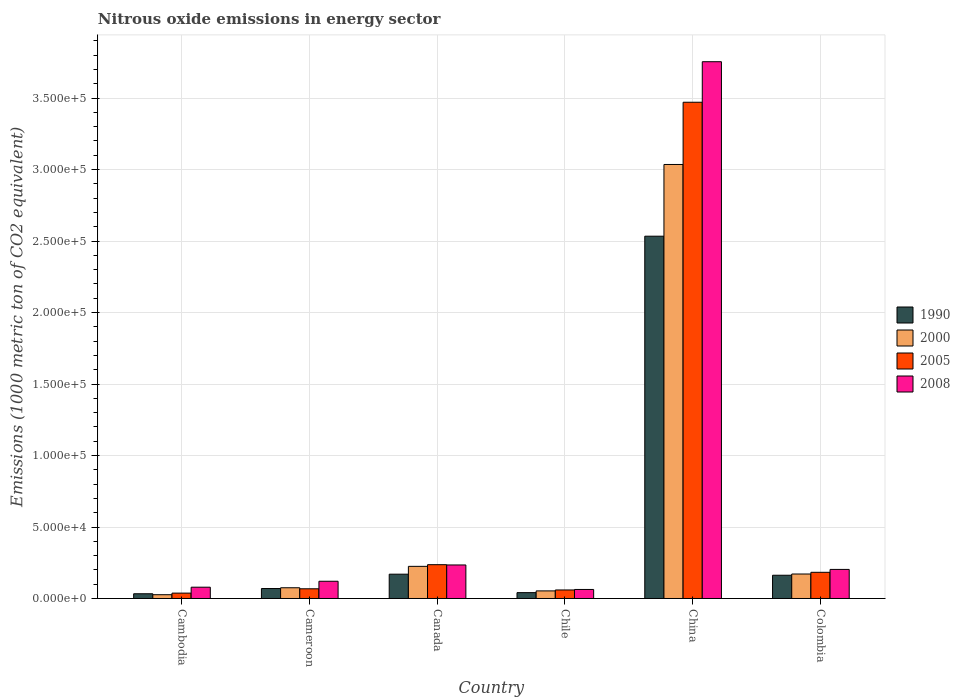How many different coloured bars are there?
Your answer should be very brief. 4. Are the number of bars on each tick of the X-axis equal?
Your answer should be compact. Yes. What is the label of the 6th group of bars from the left?
Make the answer very short. Colombia. What is the amount of nitrous oxide emitted in 2005 in China?
Make the answer very short. 3.47e+05. Across all countries, what is the maximum amount of nitrous oxide emitted in 1990?
Give a very brief answer. 2.53e+05. Across all countries, what is the minimum amount of nitrous oxide emitted in 2005?
Provide a short and direct response. 3761.1. In which country was the amount of nitrous oxide emitted in 2000 minimum?
Make the answer very short. Cambodia. What is the total amount of nitrous oxide emitted in 2008 in the graph?
Your response must be concise. 4.45e+05. What is the difference between the amount of nitrous oxide emitted in 2005 in Canada and that in Colombia?
Offer a very short reply. 5332.3. What is the difference between the amount of nitrous oxide emitted in 1990 in Canada and the amount of nitrous oxide emitted in 2000 in Cambodia?
Offer a very short reply. 1.44e+04. What is the average amount of nitrous oxide emitted in 2005 per country?
Your answer should be very brief. 6.76e+04. What is the difference between the amount of nitrous oxide emitted of/in 2008 and amount of nitrous oxide emitted of/in 1990 in Canada?
Provide a succinct answer. 6448.9. In how many countries, is the amount of nitrous oxide emitted in 2008 greater than 110000 1000 metric ton?
Give a very brief answer. 1. What is the ratio of the amount of nitrous oxide emitted in 1990 in Cameroon to that in Colombia?
Provide a short and direct response. 0.43. What is the difference between the highest and the second highest amount of nitrous oxide emitted in 2005?
Provide a succinct answer. -3.23e+05. What is the difference between the highest and the lowest amount of nitrous oxide emitted in 2000?
Your answer should be very brief. 3.01e+05. What does the 1st bar from the left in Chile represents?
Your answer should be compact. 1990. Is it the case that in every country, the sum of the amount of nitrous oxide emitted in 2008 and amount of nitrous oxide emitted in 2005 is greater than the amount of nitrous oxide emitted in 2000?
Make the answer very short. Yes. Are all the bars in the graph horizontal?
Offer a terse response. No. How many countries are there in the graph?
Provide a succinct answer. 6. Are the values on the major ticks of Y-axis written in scientific E-notation?
Give a very brief answer. Yes. Does the graph contain grids?
Offer a terse response. Yes. Where does the legend appear in the graph?
Make the answer very short. Center right. What is the title of the graph?
Your answer should be very brief. Nitrous oxide emissions in energy sector. Does "1964" appear as one of the legend labels in the graph?
Your response must be concise. No. What is the label or title of the X-axis?
Give a very brief answer. Country. What is the label or title of the Y-axis?
Keep it short and to the point. Emissions (1000 metric ton of CO2 equivalent). What is the Emissions (1000 metric ton of CO2 equivalent) in 1990 in Cambodia?
Ensure brevity in your answer.  3309.2. What is the Emissions (1000 metric ton of CO2 equivalent) of 2000 in Cambodia?
Your answer should be very brief. 2644.9. What is the Emissions (1000 metric ton of CO2 equivalent) in 2005 in Cambodia?
Provide a short and direct response. 3761.1. What is the Emissions (1000 metric ton of CO2 equivalent) in 2008 in Cambodia?
Give a very brief answer. 7902.7. What is the Emissions (1000 metric ton of CO2 equivalent) in 1990 in Cameroon?
Give a very brief answer. 6970.1. What is the Emissions (1000 metric ton of CO2 equivalent) of 2000 in Cameroon?
Give a very brief answer. 7501.6. What is the Emissions (1000 metric ton of CO2 equivalent) in 2005 in Cameroon?
Offer a very short reply. 6781.9. What is the Emissions (1000 metric ton of CO2 equivalent) in 2008 in Cameroon?
Your response must be concise. 1.21e+04. What is the Emissions (1000 metric ton of CO2 equivalent) in 1990 in Canada?
Offer a very short reply. 1.70e+04. What is the Emissions (1000 metric ton of CO2 equivalent) in 2000 in Canada?
Keep it short and to the point. 2.25e+04. What is the Emissions (1000 metric ton of CO2 equivalent) of 2005 in Canada?
Offer a very short reply. 2.36e+04. What is the Emissions (1000 metric ton of CO2 equivalent) of 2008 in Canada?
Offer a terse response. 2.34e+04. What is the Emissions (1000 metric ton of CO2 equivalent) in 1990 in Chile?
Provide a succinct answer. 4097. What is the Emissions (1000 metric ton of CO2 equivalent) in 2000 in Chile?
Offer a very short reply. 5305.7. What is the Emissions (1000 metric ton of CO2 equivalent) of 2005 in Chile?
Keep it short and to the point. 5967.8. What is the Emissions (1000 metric ton of CO2 equivalent) in 2008 in Chile?
Offer a very short reply. 6312. What is the Emissions (1000 metric ton of CO2 equivalent) of 1990 in China?
Provide a short and direct response. 2.53e+05. What is the Emissions (1000 metric ton of CO2 equivalent) in 2000 in China?
Your answer should be compact. 3.04e+05. What is the Emissions (1000 metric ton of CO2 equivalent) of 2005 in China?
Give a very brief answer. 3.47e+05. What is the Emissions (1000 metric ton of CO2 equivalent) of 2008 in China?
Provide a short and direct response. 3.75e+05. What is the Emissions (1000 metric ton of CO2 equivalent) of 1990 in Colombia?
Keep it short and to the point. 1.63e+04. What is the Emissions (1000 metric ton of CO2 equivalent) in 2000 in Colombia?
Make the answer very short. 1.71e+04. What is the Emissions (1000 metric ton of CO2 equivalent) of 2005 in Colombia?
Make the answer very short. 1.83e+04. What is the Emissions (1000 metric ton of CO2 equivalent) in 2008 in Colombia?
Keep it short and to the point. 2.03e+04. Across all countries, what is the maximum Emissions (1000 metric ton of CO2 equivalent) in 1990?
Offer a very short reply. 2.53e+05. Across all countries, what is the maximum Emissions (1000 metric ton of CO2 equivalent) of 2000?
Provide a succinct answer. 3.04e+05. Across all countries, what is the maximum Emissions (1000 metric ton of CO2 equivalent) in 2005?
Your answer should be compact. 3.47e+05. Across all countries, what is the maximum Emissions (1000 metric ton of CO2 equivalent) in 2008?
Provide a succinct answer. 3.75e+05. Across all countries, what is the minimum Emissions (1000 metric ton of CO2 equivalent) of 1990?
Provide a short and direct response. 3309.2. Across all countries, what is the minimum Emissions (1000 metric ton of CO2 equivalent) of 2000?
Ensure brevity in your answer.  2644.9. Across all countries, what is the minimum Emissions (1000 metric ton of CO2 equivalent) of 2005?
Offer a very short reply. 3761.1. Across all countries, what is the minimum Emissions (1000 metric ton of CO2 equivalent) in 2008?
Your response must be concise. 6312. What is the total Emissions (1000 metric ton of CO2 equivalent) of 1990 in the graph?
Keep it short and to the point. 3.01e+05. What is the total Emissions (1000 metric ton of CO2 equivalent) of 2000 in the graph?
Offer a terse response. 3.59e+05. What is the total Emissions (1000 metric ton of CO2 equivalent) of 2005 in the graph?
Make the answer very short. 4.06e+05. What is the total Emissions (1000 metric ton of CO2 equivalent) in 2008 in the graph?
Make the answer very short. 4.45e+05. What is the difference between the Emissions (1000 metric ton of CO2 equivalent) of 1990 in Cambodia and that in Cameroon?
Your answer should be compact. -3660.9. What is the difference between the Emissions (1000 metric ton of CO2 equivalent) of 2000 in Cambodia and that in Cameroon?
Offer a terse response. -4856.7. What is the difference between the Emissions (1000 metric ton of CO2 equivalent) in 2005 in Cambodia and that in Cameroon?
Offer a terse response. -3020.8. What is the difference between the Emissions (1000 metric ton of CO2 equivalent) of 2008 in Cambodia and that in Cameroon?
Provide a succinct answer. -4150.2. What is the difference between the Emissions (1000 metric ton of CO2 equivalent) in 1990 in Cambodia and that in Canada?
Offer a very short reply. -1.37e+04. What is the difference between the Emissions (1000 metric ton of CO2 equivalent) in 2000 in Cambodia and that in Canada?
Give a very brief answer. -1.98e+04. What is the difference between the Emissions (1000 metric ton of CO2 equivalent) in 2005 in Cambodia and that in Canada?
Give a very brief answer. -1.99e+04. What is the difference between the Emissions (1000 metric ton of CO2 equivalent) in 2008 in Cambodia and that in Canada?
Your answer should be very brief. -1.55e+04. What is the difference between the Emissions (1000 metric ton of CO2 equivalent) in 1990 in Cambodia and that in Chile?
Offer a very short reply. -787.8. What is the difference between the Emissions (1000 metric ton of CO2 equivalent) of 2000 in Cambodia and that in Chile?
Make the answer very short. -2660.8. What is the difference between the Emissions (1000 metric ton of CO2 equivalent) in 2005 in Cambodia and that in Chile?
Give a very brief answer. -2206.7. What is the difference between the Emissions (1000 metric ton of CO2 equivalent) in 2008 in Cambodia and that in Chile?
Keep it short and to the point. 1590.7. What is the difference between the Emissions (1000 metric ton of CO2 equivalent) in 1990 in Cambodia and that in China?
Make the answer very short. -2.50e+05. What is the difference between the Emissions (1000 metric ton of CO2 equivalent) in 2000 in Cambodia and that in China?
Your answer should be compact. -3.01e+05. What is the difference between the Emissions (1000 metric ton of CO2 equivalent) in 2005 in Cambodia and that in China?
Give a very brief answer. -3.43e+05. What is the difference between the Emissions (1000 metric ton of CO2 equivalent) in 2008 in Cambodia and that in China?
Your answer should be compact. -3.68e+05. What is the difference between the Emissions (1000 metric ton of CO2 equivalent) in 1990 in Cambodia and that in Colombia?
Give a very brief answer. -1.30e+04. What is the difference between the Emissions (1000 metric ton of CO2 equivalent) of 2000 in Cambodia and that in Colombia?
Give a very brief answer. -1.45e+04. What is the difference between the Emissions (1000 metric ton of CO2 equivalent) of 2005 in Cambodia and that in Colombia?
Your response must be concise. -1.45e+04. What is the difference between the Emissions (1000 metric ton of CO2 equivalent) of 2008 in Cambodia and that in Colombia?
Your answer should be very brief. -1.24e+04. What is the difference between the Emissions (1000 metric ton of CO2 equivalent) in 1990 in Cameroon and that in Canada?
Offer a very short reply. -1.00e+04. What is the difference between the Emissions (1000 metric ton of CO2 equivalent) in 2000 in Cameroon and that in Canada?
Offer a very short reply. -1.50e+04. What is the difference between the Emissions (1000 metric ton of CO2 equivalent) in 2005 in Cameroon and that in Canada?
Keep it short and to the point. -1.69e+04. What is the difference between the Emissions (1000 metric ton of CO2 equivalent) of 2008 in Cameroon and that in Canada?
Give a very brief answer. -1.14e+04. What is the difference between the Emissions (1000 metric ton of CO2 equivalent) of 1990 in Cameroon and that in Chile?
Your answer should be compact. 2873.1. What is the difference between the Emissions (1000 metric ton of CO2 equivalent) in 2000 in Cameroon and that in Chile?
Offer a terse response. 2195.9. What is the difference between the Emissions (1000 metric ton of CO2 equivalent) of 2005 in Cameroon and that in Chile?
Make the answer very short. 814.1. What is the difference between the Emissions (1000 metric ton of CO2 equivalent) of 2008 in Cameroon and that in Chile?
Offer a very short reply. 5740.9. What is the difference between the Emissions (1000 metric ton of CO2 equivalent) in 1990 in Cameroon and that in China?
Your answer should be compact. -2.46e+05. What is the difference between the Emissions (1000 metric ton of CO2 equivalent) in 2000 in Cameroon and that in China?
Offer a terse response. -2.96e+05. What is the difference between the Emissions (1000 metric ton of CO2 equivalent) of 2005 in Cameroon and that in China?
Give a very brief answer. -3.40e+05. What is the difference between the Emissions (1000 metric ton of CO2 equivalent) in 2008 in Cameroon and that in China?
Your answer should be very brief. -3.63e+05. What is the difference between the Emissions (1000 metric ton of CO2 equivalent) of 1990 in Cameroon and that in Colombia?
Offer a terse response. -9292. What is the difference between the Emissions (1000 metric ton of CO2 equivalent) in 2000 in Cameroon and that in Colombia?
Provide a succinct answer. -9624.9. What is the difference between the Emissions (1000 metric ton of CO2 equivalent) of 2005 in Cameroon and that in Colombia?
Make the answer very short. -1.15e+04. What is the difference between the Emissions (1000 metric ton of CO2 equivalent) in 2008 in Cameroon and that in Colombia?
Your response must be concise. -8286.7. What is the difference between the Emissions (1000 metric ton of CO2 equivalent) of 1990 in Canada and that in Chile?
Your answer should be compact. 1.29e+04. What is the difference between the Emissions (1000 metric ton of CO2 equivalent) of 2000 in Canada and that in Chile?
Your answer should be compact. 1.72e+04. What is the difference between the Emissions (1000 metric ton of CO2 equivalent) of 2005 in Canada and that in Chile?
Offer a terse response. 1.77e+04. What is the difference between the Emissions (1000 metric ton of CO2 equivalent) of 2008 in Canada and that in Chile?
Offer a very short reply. 1.71e+04. What is the difference between the Emissions (1000 metric ton of CO2 equivalent) in 1990 in Canada and that in China?
Provide a succinct answer. -2.36e+05. What is the difference between the Emissions (1000 metric ton of CO2 equivalent) of 2000 in Canada and that in China?
Keep it short and to the point. -2.81e+05. What is the difference between the Emissions (1000 metric ton of CO2 equivalent) in 2005 in Canada and that in China?
Your answer should be very brief. -3.23e+05. What is the difference between the Emissions (1000 metric ton of CO2 equivalent) of 2008 in Canada and that in China?
Provide a short and direct response. -3.52e+05. What is the difference between the Emissions (1000 metric ton of CO2 equivalent) of 1990 in Canada and that in Colombia?
Your answer should be very brief. 737.3. What is the difference between the Emissions (1000 metric ton of CO2 equivalent) in 2000 in Canada and that in Colombia?
Make the answer very short. 5354.3. What is the difference between the Emissions (1000 metric ton of CO2 equivalent) of 2005 in Canada and that in Colombia?
Your answer should be compact. 5332.3. What is the difference between the Emissions (1000 metric ton of CO2 equivalent) of 2008 in Canada and that in Colombia?
Keep it short and to the point. 3108.7. What is the difference between the Emissions (1000 metric ton of CO2 equivalent) in 1990 in Chile and that in China?
Provide a short and direct response. -2.49e+05. What is the difference between the Emissions (1000 metric ton of CO2 equivalent) in 2000 in Chile and that in China?
Offer a very short reply. -2.98e+05. What is the difference between the Emissions (1000 metric ton of CO2 equivalent) of 2005 in Chile and that in China?
Offer a very short reply. -3.41e+05. What is the difference between the Emissions (1000 metric ton of CO2 equivalent) of 2008 in Chile and that in China?
Offer a terse response. -3.69e+05. What is the difference between the Emissions (1000 metric ton of CO2 equivalent) in 1990 in Chile and that in Colombia?
Give a very brief answer. -1.22e+04. What is the difference between the Emissions (1000 metric ton of CO2 equivalent) in 2000 in Chile and that in Colombia?
Provide a succinct answer. -1.18e+04. What is the difference between the Emissions (1000 metric ton of CO2 equivalent) of 2005 in Chile and that in Colombia?
Offer a very short reply. -1.23e+04. What is the difference between the Emissions (1000 metric ton of CO2 equivalent) of 2008 in Chile and that in Colombia?
Your answer should be very brief. -1.40e+04. What is the difference between the Emissions (1000 metric ton of CO2 equivalent) of 1990 in China and that in Colombia?
Make the answer very short. 2.37e+05. What is the difference between the Emissions (1000 metric ton of CO2 equivalent) of 2000 in China and that in Colombia?
Provide a succinct answer. 2.86e+05. What is the difference between the Emissions (1000 metric ton of CO2 equivalent) in 2005 in China and that in Colombia?
Keep it short and to the point. 3.29e+05. What is the difference between the Emissions (1000 metric ton of CO2 equivalent) of 2008 in China and that in Colombia?
Your answer should be very brief. 3.55e+05. What is the difference between the Emissions (1000 metric ton of CO2 equivalent) of 1990 in Cambodia and the Emissions (1000 metric ton of CO2 equivalent) of 2000 in Cameroon?
Offer a very short reply. -4192.4. What is the difference between the Emissions (1000 metric ton of CO2 equivalent) in 1990 in Cambodia and the Emissions (1000 metric ton of CO2 equivalent) in 2005 in Cameroon?
Ensure brevity in your answer.  -3472.7. What is the difference between the Emissions (1000 metric ton of CO2 equivalent) in 1990 in Cambodia and the Emissions (1000 metric ton of CO2 equivalent) in 2008 in Cameroon?
Make the answer very short. -8743.7. What is the difference between the Emissions (1000 metric ton of CO2 equivalent) of 2000 in Cambodia and the Emissions (1000 metric ton of CO2 equivalent) of 2005 in Cameroon?
Keep it short and to the point. -4137. What is the difference between the Emissions (1000 metric ton of CO2 equivalent) in 2000 in Cambodia and the Emissions (1000 metric ton of CO2 equivalent) in 2008 in Cameroon?
Make the answer very short. -9408. What is the difference between the Emissions (1000 metric ton of CO2 equivalent) of 2005 in Cambodia and the Emissions (1000 metric ton of CO2 equivalent) of 2008 in Cameroon?
Keep it short and to the point. -8291.8. What is the difference between the Emissions (1000 metric ton of CO2 equivalent) in 1990 in Cambodia and the Emissions (1000 metric ton of CO2 equivalent) in 2000 in Canada?
Ensure brevity in your answer.  -1.92e+04. What is the difference between the Emissions (1000 metric ton of CO2 equivalent) of 1990 in Cambodia and the Emissions (1000 metric ton of CO2 equivalent) of 2005 in Canada?
Give a very brief answer. -2.03e+04. What is the difference between the Emissions (1000 metric ton of CO2 equivalent) in 1990 in Cambodia and the Emissions (1000 metric ton of CO2 equivalent) in 2008 in Canada?
Make the answer very short. -2.01e+04. What is the difference between the Emissions (1000 metric ton of CO2 equivalent) of 2000 in Cambodia and the Emissions (1000 metric ton of CO2 equivalent) of 2005 in Canada?
Your response must be concise. -2.10e+04. What is the difference between the Emissions (1000 metric ton of CO2 equivalent) of 2000 in Cambodia and the Emissions (1000 metric ton of CO2 equivalent) of 2008 in Canada?
Keep it short and to the point. -2.08e+04. What is the difference between the Emissions (1000 metric ton of CO2 equivalent) of 2005 in Cambodia and the Emissions (1000 metric ton of CO2 equivalent) of 2008 in Canada?
Ensure brevity in your answer.  -1.97e+04. What is the difference between the Emissions (1000 metric ton of CO2 equivalent) in 1990 in Cambodia and the Emissions (1000 metric ton of CO2 equivalent) in 2000 in Chile?
Ensure brevity in your answer.  -1996.5. What is the difference between the Emissions (1000 metric ton of CO2 equivalent) in 1990 in Cambodia and the Emissions (1000 metric ton of CO2 equivalent) in 2005 in Chile?
Keep it short and to the point. -2658.6. What is the difference between the Emissions (1000 metric ton of CO2 equivalent) of 1990 in Cambodia and the Emissions (1000 metric ton of CO2 equivalent) of 2008 in Chile?
Provide a short and direct response. -3002.8. What is the difference between the Emissions (1000 metric ton of CO2 equivalent) of 2000 in Cambodia and the Emissions (1000 metric ton of CO2 equivalent) of 2005 in Chile?
Make the answer very short. -3322.9. What is the difference between the Emissions (1000 metric ton of CO2 equivalent) in 2000 in Cambodia and the Emissions (1000 metric ton of CO2 equivalent) in 2008 in Chile?
Make the answer very short. -3667.1. What is the difference between the Emissions (1000 metric ton of CO2 equivalent) in 2005 in Cambodia and the Emissions (1000 metric ton of CO2 equivalent) in 2008 in Chile?
Your response must be concise. -2550.9. What is the difference between the Emissions (1000 metric ton of CO2 equivalent) of 1990 in Cambodia and the Emissions (1000 metric ton of CO2 equivalent) of 2000 in China?
Your answer should be compact. -3.00e+05. What is the difference between the Emissions (1000 metric ton of CO2 equivalent) of 1990 in Cambodia and the Emissions (1000 metric ton of CO2 equivalent) of 2005 in China?
Provide a short and direct response. -3.44e+05. What is the difference between the Emissions (1000 metric ton of CO2 equivalent) in 1990 in Cambodia and the Emissions (1000 metric ton of CO2 equivalent) in 2008 in China?
Provide a succinct answer. -3.72e+05. What is the difference between the Emissions (1000 metric ton of CO2 equivalent) in 2000 in Cambodia and the Emissions (1000 metric ton of CO2 equivalent) in 2005 in China?
Ensure brevity in your answer.  -3.44e+05. What is the difference between the Emissions (1000 metric ton of CO2 equivalent) of 2000 in Cambodia and the Emissions (1000 metric ton of CO2 equivalent) of 2008 in China?
Keep it short and to the point. -3.73e+05. What is the difference between the Emissions (1000 metric ton of CO2 equivalent) of 2005 in Cambodia and the Emissions (1000 metric ton of CO2 equivalent) of 2008 in China?
Your response must be concise. -3.72e+05. What is the difference between the Emissions (1000 metric ton of CO2 equivalent) in 1990 in Cambodia and the Emissions (1000 metric ton of CO2 equivalent) in 2000 in Colombia?
Offer a very short reply. -1.38e+04. What is the difference between the Emissions (1000 metric ton of CO2 equivalent) of 1990 in Cambodia and the Emissions (1000 metric ton of CO2 equivalent) of 2005 in Colombia?
Offer a terse response. -1.50e+04. What is the difference between the Emissions (1000 metric ton of CO2 equivalent) of 1990 in Cambodia and the Emissions (1000 metric ton of CO2 equivalent) of 2008 in Colombia?
Provide a short and direct response. -1.70e+04. What is the difference between the Emissions (1000 metric ton of CO2 equivalent) in 2000 in Cambodia and the Emissions (1000 metric ton of CO2 equivalent) in 2005 in Colombia?
Your answer should be very brief. -1.57e+04. What is the difference between the Emissions (1000 metric ton of CO2 equivalent) in 2000 in Cambodia and the Emissions (1000 metric ton of CO2 equivalent) in 2008 in Colombia?
Make the answer very short. -1.77e+04. What is the difference between the Emissions (1000 metric ton of CO2 equivalent) of 2005 in Cambodia and the Emissions (1000 metric ton of CO2 equivalent) of 2008 in Colombia?
Make the answer very short. -1.66e+04. What is the difference between the Emissions (1000 metric ton of CO2 equivalent) in 1990 in Cameroon and the Emissions (1000 metric ton of CO2 equivalent) in 2000 in Canada?
Ensure brevity in your answer.  -1.55e+04. What is the difference between the Emissions (1000 metric ton of CO2 equivalent) in 1990 in Cameroon and the Emissions (1000 metric ton of CO2 equivalent) in 2005 in Canada?
Offer a terse response. -1.67e+04. What is the difference between the Emissions (1000 metric ton of CO2 equivalent) of 1990 in Cameroon and the Emissions (1000 metric ton of CO2 equivalent) of 2008 in Canada?
Keep it short and to the point. -1.65e+04. What is the difference between the Emissions (1000 metric ton of CO2 equivalent) in 2000 in Cameroon and the Emissions (1000 metric ton of CO2 equivalent) in 2005 in Canada?
Make the answer very short. -1.61e+04. What is the difference between the Emissions (1000 metric ton of CO2 equivalent) in 2000 in Cameroon and the Emissions (1000 metric ton of CO2 equivalent) in 2008 in Canada?
Your response must be concise. -1.59e+04. What is the difference between the Emissions (1000 metric ton of CO2 equivalent) of 2005 in Cameroon and the Emissions (1000 metric ton of CO2 equivalent) of 2008 in Canada?
Ensure brevity in your answer.  -1.67e+04. What is the difference between the Emissions (1000 metric ton of CO2 equivalent) in 1990 in Cameroon and the Emissions (1000 metric ton of CO2 equivalent) in 2000 in Chile?
Provide a short and direct response. 1664.4. What is the difference between the Emissions (1000 metric ton of CO2 equivalent) in 1990 in Cameroon and the Emissions (1000 metric ton of CO2 equivalent) in 2005 in Chile?
Ensure brevity in your answer.  1002.3. What is the difference between the Emissions (1000 metric ton of CO2 equivalent) of 1990 in Cameroon and the Emissions (1000 metric ton of CO2 equivalent) of 2008 in Chile?
Keep it short and to the point. 658.1. What is the difference between the Emissions (1000 metric ton of CO2 equivalent) of 2000 in Cameroon and the Emissions (1000 metric ton of CO2 equivalent) of 2005 in Chile?
Make the answer very short. 1533.8. What is the difference between the Emissions (1000 metric ton of CO2 equivalent) in 2000 in Cameroon and the Emissions (1000 metric ton of CO2 equivalent) in 2008 in Chile?
Provide a succinct answer. 1189.6. What is the difference between the Emissions (1000 metric ton of CO2 equivalent) in 2005 in Cameroon and the Emissions (1000 metric ton of CO2 equivalent) in 2008 in Chile?
Provide a short and direct response. 469.9. What is the difference between the Emissions (1000 metric ton of CO2 equivalent) of 1990 in Cameroon and the Emissions (1000 metric ton of CO2 equivalent) of 2000 in China?
Provide a succinct answer. -2.97e+05. What is the difference between the Emissions (1000 metric ton of CO2 equivalent) in 1990 in Cameroon and the Emissions (1000 metric ton of CO2 equivalent) in 2005 in China?
Offer a terse response. -3.40e+05. What is the difference between the Emissions (1000 metric ton of CO2 equivalent) of 1990 in Cameroon and the Emissions (1000 metric ton of CO2 equivalent) of 2008 in China?
Your response must be concise. -3.68e+05. What is the difference between the Emissions (1000 metric ton of CO2 equivalent) in 2000 in Cameroon and the Emissions (1000 metric ton of CO2 equivalent) in 2005 in China?
Your answer should be very brief. -3.40e+05. What is the difference between the Emissions (1000 metric ton of CO2 equivalent) of 2000 in Cameroon and the Emissions (1000 metric ton of CO2 equivalent) of 2008 in China?
Keep it short and to the point. -3.68e+05. What is the difference between the Emissions (1000 metric ton of CO2 equivalent) in 2005 in Cameroon and the Emissions (1000 metric ton of CO2 equivalent) in 2008 in China?
Ensure brevity in your answer.  -3.69e+05. What is the difference between the Emissions (1000 metric ton of CO2 equivalent) of 1990 in Cameroon and the Emissions (1000 metric ton of CO2 equivalent) of 2000 in Colombia?
Provide a succinct answer. -1.02e+04. What is the difference between the Emissions (1000 metric ton of CO2 equivalent) in 1990 in Cameroon and the Emissions (1000 metric ton of CO2 equivalent) in 2005 in Colombia?
Provide a short and direct response. -1.13e+04. What is the difference between the Emissions (1000 metric ton of CO2 equivalent) of 1990 in Cameroon and the Emissions (1000 metric ton of CO2 equivalent) of 2008 in Colombia?
Provide a succinct answer. -1.34e+04. What is the difference between the Emissions (1000 metric ton of CO2 equivalent) in 2000 in Cameroon and the Emissions (1000 metric ton of CO2 equivalent) in 2005 in Colombia?
Your answer should be very brief. -1.08e+04. What is the difference between the Emissions (1000 metric ton of CO2 equivalent) in 2000 in Cameroon and the Emissions (1000 metric ton of CO2 equivalent) in 2008 in Colombia?
Offer a very short reply. -1.28e+04. What is the difference between the Emissions (1000 metric ton of CO2 equivalent) of 2005 in Cameroon and the Emissions (1000 metric ton of CO2 equivalent) of 2008 in Colombia?
Offer a terse response. -1.36e+04. What is the difference between the Emissions (1000 metric ton of CO2 equivalent) in 1990 in Canada and the Emissions (1000 metric ton of CO2 equivalent) in 2000 in Chile?
Offer a very short reply. 1.17e+04. What is the difference between the Emissions (1000 metric ton of CO2 equivalent) in 1990 in Canada and the Emissions (1000 metric ton of CO2 equivalent) in 2005 in Chile?
Provide a succinct answer. 1.10e+04. What is the difference between the Emissions (1000 metric ton of CO2 equivalent) of 1990 in Canada and the Emissions (1000 metric ton of CO2 equivalent) of 2008 in Chile?
Your answer should be very brief. 1.07e+04. What is the difference between the Emissions (1000 metric ton of CO2 equivalent) in 2000 in Canada and the Emissions (1000 metric ton of CO2 equivalent) in 2005 in Chile?
Keep it short and to the point. 1.65e+04. What is the difference between the Emissions (1000 metric ton of CO2 equivalent) of 2000 in Canada and the Emissions (1000 metric ton of CO2 equivalent) of 2008 in Chile?
Ensure brevity in your answer.  1.62e+04. What is the difference between the Emissions (1000 metric ton of CO2 equivalent) of 2005 in Canada and the Emissions (1000 metric ton of CO2 equivalent) of 2008 in Chile?
Provide a succinct answer. 1.73e+04. What is the difference between the Emissions (1000 metric ton of CO2 equivalent) of 1990 in Canada and the Emissions (1000 metric ton of CO2 equivalent) of 2000 in China?
Give a very brief answer. -2.87e+05. What is the difference between the Emissions (1000 metric ton of CO2 equivalent) of 1990 in Canada and the Emissions (1000 metric ton of CO2 equivalent) of 2005 in China?
Offer a very short reply. -3.30e+05. What is the difference between the Emissions (1000 metric ton of CO2 equivalent) in 1990 in Canada and the Emissions (1000 metric ton of CO2 equivalent) in 2008 in China?
Make the answer very short. -3.58e+05. What is the difference between the Emissions (1000 metric ton of CO2 equivalent) of 2000 in Canada and the Emissions (1000 metric ton of CO2 equivalent) of 2005 in China?
Ensure brevity in your answer.  -3.25e+05. What is the difference between the Emissions (1000 metric ton of CO2 equivalent) in 2000 in Canada and the Emissions (1000 metric ton of CO2 equivalent) in 2008 in China?
Your answer should be compact. -3.53e+05. What is the difference between the Emissions (1000 metric ton of CO2 equivalent) in 2005 in Canada and the Emissions (1000 metric ton of CO2 equivalent) in 2008 in China?
Make the answer very short. -3.52e+05. What is the difference between the Emissions (1000 metric ton of CO2 equivalent) in 1990 in Canada and the Emissions (1000 metric ton of CO2 equivalent) in 2000 in Colombia?
Offer a terse response. -127.1. What is the difference between the Emissions (1000 metric ton of CO2 equivalent) in 1990 in Canada and the Emissions (1000 metric ton of CO2 equivalent) in 2005 in Colombia?
Give a very brief answer. -1310.3. What is the difference between the Emissions (1000 metric ton of CO2 equivalent) in 1990 in Canada and the Emissions (1000 metric ton of CO2 equivalent) in 2008 in Colombia?
Give a very brief answer. -3340.2. What is the difference between the Emissions (1000 metric ton of CO2 equivalent) in 2000 in Canada and the Emissions (1000 metric ton of CO2 equivalent) in 2005 in Colombia?
Make the answer very short. 4171.1. What is the difference between the Emissions (1000 metric ton of CO2 equivalent) of 2000 in Canada and the Emissions (1000 metric ton of CO2 equivalent) of 2008 in Colombia?
Provide a short and direct response. 2141.2. What is the difference between the Emissions (1000 metric ton of CO2 equivalent) in 2005 in Canada and the Emissions (1000 metric ton of CO2 equivalent) in 2008 in Colombia?
Give a very brief answer. 3302.4. What is the difference between the Emissions (1000 metric ton of CO2 equivalent) in 1990 in Chile and the Emissions (1000 metric ton of CO2 equivalent) in 2000 in China?
Your response must be concise. -2.99e+05. What is the difference between the Emissions (1000 metric ton of CO2 equivalent) of 1990 in Chile and the Emissions (1000 metric ton of CO2 equivalent) of 2005 in China?
Offer a very short reply. -3.43e+05. What is the difference between the Emissions (1000 metric ton of CO2 equivalent) in 1990 in Chile and the Emissions (1000 metric ton of CO2 equivalent) in 2008 in China?
Your response must be concise. -3.71e+05. What is the difference between the Emissions (1000 metric ton of CO2 equivalent) in 2000 in Chile and the Emissions (1000 metric ton of CO2 equivalent) in 2005 in China?
Give a very brief answer. -3.42e+05. What is the difference between the Emissions (1000 metric ton of CO2 equivalent) of 2000 in Chile and the Emissions (1000 metric ton of CO2 equivalent) of 2008 in China?
Your response must be concise. -3.70e+05. What is the difference between the Emissions (1000 metric ton of CO2 equivalent) in 2005 in Chile and the Emissions (1000 metric ton of CO2 equivalent) in 2008 in China?
Your response must be concise. -3.69e+05. What is the difference between the Emissions (1000 metric ton of CO2 equivalent) in 1990 in Chile and the Emissions (1000 metric ton of CO2 equivalent) in 2000 in Colombia?
Offer a terse response. -1.30e+04. What is the difference between the Emissions (1000 metric ton of CO2 equivalent) in 1990 in Chile and the Emissions (1000 metric ton of CO2 equivalent) in 2005 in Colombia?
Give a very brief answer. -1.42e+04. What is the difference between the Emissions (1000 metric ton of CO2 equivalent) of 1990 in Chile and the Emissions (1000 metric ton of CO2 equivalent) of 2008 in Colombia?
Your response must be concise. -1.62e+04. What is the difference between the Emissions (1000 metric ton of CO2 equivalent) in 2000 in Chile and the Emissions (1000 metric ton of CO2 equivalent) in 2005 in Colombia?
Provide a short and direct response. -1.30e+04. What is the difference between the Emissions (1000 metric ton of CO2 equivalent) of 2000 in Chile and the Emissions (1000 metric ton of CO2 equivalent) of 2008 in Colombia?
Offer a very short reply. -1.50e+04. What is the difference between the Emissions (1000 metric ton of CO2 equivalent) in 2005 in Chile and the Emissions (1000 metric ton of CO2 equivalent) in 2008 in Colombia?
Your answer should be very brief. -1.44e+04. What is the difference between the Emissions (1000 metric ton of CO2 equivalent) in 1990 in China and the Emissions (1000 metric ton of CO2 equivalent) in 2000 in Colombia?
Provide a succinct answer. 2.36e+05. What is the difference between the Emissions (1000 metric ton of CO2 equivalent) of 1990 in China and the Emissions (1000 metric ton of CO2 equivalent) of 2005 in Colombia?
Offer a very short reply. 2.35e+05. What is the difference between the Emissions (1000 metric ton of CO2 equivalent) of 1990 in China and the Emissions (1000 metric ton of CO2 equivalent) of 2008 in Colombia?
Provide a succinct answer. 2.33e+05. What is the difference between the Emissions (1000 metric ton of CO2 equivalent) of 2000 in China and the Emissions (1000 metric ton of CO2 equivalent) of 2005 in Colombia?
Your answer should be very brief. 2.85e+05. What is the difference between the Emissions (1000 metric ton of CO2 equivalent) in 2000 in China and the Emissions (1000 metric ton of CO2 equivalent) in 2008 in Colombia?
Your answer should be very brief. 2.83e+05. What is the difference between the Emissions (1000 metric ton of CO2 equivalent) of 2005 in China and the Emissions (1000 metric ton of CO2 equivalent) of 2008 in Colombia?
Provide a short and direct response. 3.27e+05. What is the average Emissions (1000 metric ton of CO2 equivalent) in 1990 per country?
Offer a terse response. 5.02e+04. What is the average Emissions (1000 metric ton of CO2 equivalent) in 2000 per country?
Offer a terse response. 5.98e+04. What is the average Emissions (1000 metric ton of CO2 equivalent) of 2005 per country?
Offer a terse response. 6.76e+04. What is the average Emissions (1000 metric ton of CO2 equivalent) of 2008 per country?
Your answer should be very brief. 7.42e+04. What is the difference between the Emissions (1000 metric ton of CO2 equivalent) of 1990 and Emissions (1000 metric ton of CO2 equivalent) of 2000 in Cambodia?
Keep it short and to the point. 664.3. What is the difference between the Emissions (1000 metric ton of CO2 equivalent) of 1990 and Emissions (1000 metric ton of CO2 equivalent) of 2005 in Cambodia?
Your response must be concise. -451.9. What is the difference between the Emissions (1000 metric ton of CO2 equivalent) of 1990 and Emissions (1000 metric ton of CO2 equivalent) of 2008 in Cambodia?
Keep it short and to the point. -4593.5. What is the difference between the Emissions (1000 metric ton of CO2 equivalent) of 2000 and Emissions (1000 metric ton of CO2 equivalent) of 2005 in Cambodia?
Your response must be concise. -1116.2. What is the difference between the Emissions (1000 metric ton of CO2 equivalent) of 2000 and Emissions (1000 metric ton of CO2 equivalent) of 2008 in Cambodia?
Provide a succinct answer. -5257.8. What is the difference between the Emissions (1000 metric ton of CO2 equivalent) in 2005 and Emissions (1000 metric ton of CO2 equivalent) in 2008 in Cambodia?
Keep it short and to the point. -4141.6. What is the difference between the Emissions (1000 metric ton of CO2 equivalent) of 1990 and Emissions (1000 metric ton of CO2 equivalent) of 2000 in Cameroon?
Provide a short and direct response. -531.5. What is the difference between the Emissions (1000 metric ton of CO2 equivalent) in 1990 and Emissions (1000 metric ton of CO2 equivalent) in 2005 in Cameroon?
Your answer should be very brief. 188.2. What is the difference between the Emissions (1000 metric ton of CO2 equivalent) of 1990 and Emissions (1000 metric ton of CO2 equivalent) of 2008 in Cameroon?
Provide a succinct answer. -5082.8. What is the difference between the Emissions (1000 metric ton of CO2 equivalent) of 2000 and Emissions (1000 metric ton of CO2 equivalent) of 2005 in Cameroon?
Your answer should be very brief. 719.7. What is the difference between the Emissions (1000 metric ton of CO2 equivalent) of 2000 and Emissions (1000 metric ton of CO2 equivalent) of 2008 in Cameroon?
Ensure brevity in your answer.  -4551.3. What is the difference between the Emissions (1000 metric ton of CO2 equivalent) of 2005 and Emissions (1000 metric ton of CO2 equivalent) of 2008 in Cameroon?
Offer a very short reply. -5271. What is the difference between the Emissions (1000 metric ton of CO2 equivalent) of 1990 and Emissions (1000 metric ton of CO2 equivalent) of 2000 in Canada?
Ensure brevity in your answer.  -5481.4. What is the difference between the Emissions (1000 metric ton of CO2 equivalent) in 1990 and Emissions (1000 metric ton of CO2 equivalent) in 2005 in Canada?
Make the answer very short. -6642.6. What is the difference between the Emissions (1000 metric ton of CO2 equivalent) of 1990 and Emissions (1000 metric ton of CO2 equivalent) of 2008 in Canada?
Make the answer very short. -6448.9. What is the difference between the Emissions (1000 metric ton of CO2 equivalent) in 2000 and Emissions (1000 metric ton of CO2 equivalent) in 2005 in Canada?
Give a very brief answer. -1161.2. What is the difference between the Emissions (1000 metric ton of CO2 equivalent) of 2000 and Emissions (1000 metric ton of CO2 equivalent) of 2008 in Canada?
Your answer should be very brief. -967.5. What is the difference between the Emissions (1000 metric ton of CO2 equivalent) in 2005 and Emissions (1000 metric ton of CO2 equivalent) in 2008 in Canada?
Your response must be concise. 193.7. What is the difference between the Emissions (1000 metric ton of CO2 equivalent) of 1990 and Emissions (1000 metric ton of CO2 equivalent) of 2000 in Chile?
Give a very brief answer. -1208.7. What is the difference between the Emissions (1000 metric ton of CO2 equivalent) in 1990 and Emissions (1000 metric ton of CO2 equivalent) in 2005 in Chile?
Give a very brief answer. -1870.8. What is the difference between the Emissions (1000 metric ton of CO2 equivalent) in 1990 and Emissions (1000 metric ton of CO2 equivalent) in 2008 in Chile?
Your response must be concise. -2215. What is the difference between the Emissions (1000 metric ton of CO2 equivalent) in 2000 and Emissions (1000 metric ton of CO2 equivalent) in 2005 in Chile?
Give a very brief answer. -662.1. What is the difference between the Emissions (1000 metric ton of CO2 equivalent) of 2000 and Emissions (1000 metric ton of CO2 equivalent) of 2008 in Chile?
Provide a short and direct response. -1006.3. What is the difference between the Emissions (1000 metric ton of CO2 equivalent) in 2005 and Emissions (1000 metric ton of CO2 equivalent) in 2008 in Chile?
Provide a succinct answer. -344.2. What is the difference between the Emissions (1000 metric ton of CO2 equivalent) in 1990 and Emissions (1000 metric ton of CO2 equivalent) in 2000 in China?
Provide a succinct answer. -5.02e+04. What is the difference between the Emissions (1000 metric ton of CO2 equivalent) in 1990 and Emissions (1000 metric ton of CO2 equivalent) in 2005 in China?
Give a very brief answer. -9.37e+04. What is the difference between the Emissions (1000 metric ton of CO2 equivalent) in 1990 and Emissions (1000 metric ton of CO2 equivalent) in 2008 in China?
Provide a short and direct response. -1.22e+05. What is the difference between the Emissions (1000 metric ton of CO2 equivalent) of 2000 and Emissions (1000 metric ton of CO2 equivalent) of 2005 in China?
Provide a succinct answer. -4.35e+04. What is the difference between the Emissions (1000 metric ton of CO2 equivalent) of 2000 and Emissions (1000 metric ton of CO2 equivalent) of 2008 in China?
Provide a succinct answer. -7.19e+04. What is the difference between the Emissions (1000 metric ton of CO2 equivalent) in 2005 and Emissions (1000 metric ton of CO2 equivalent) in 2008 in China?
Ensure brevity in your answer.  -2.83e+04. What is the difference between the Emissions (1000 metric ton of CO2 equivalent) in 1990 and Emissions (1000 metric ton of CO2 equivalent) in 2000 in Colombia?
Give a very brief answer. -864.4. What is the difference between the Emissions (1000 metric ton of CO2 equivalent) in 1990 and Emissions (1000 metric ton of CO2 equivalent) in 2005 in Colombia?
Your answer should be very brief. -2047.6. What is the difference between the Emissions (1000 metric ton of CO2 equivalent) in 1990 and Emissions (1000 metric ton of CO2 equivalent) in 2008 in Colombia?
Make the answer very short. -4077.5. What is the difference between the Emissions (1000 metric ton of CO2 equivalent) in 2000 and Emissions (1000 metric ton of CO2 equivalent) in 2005 in Colombia?
Give a very brief answer. -1183.2. What is the difference between the Emissions (1000 metric ton of CO2 equivalent) of 2000 and Emissions (1000 metric ton of CO2 equivalent) of 2008 in Colombia?
Make the answer very short. -3213.1. What is the difference between the Emissions (1000 metric ton of CO2 equivalent) in 2005 and Emissions (1000 metric ton of CO2 equivalent) in 2008 in Colombia?
Make the answer very short. -2029.9. What is the ratio of the Emissions (1000 metric ton of CO2 equivalent) of 1990 in Cambodia to that in Cameroon?
Your answer should be compact. 0.47. What is the ratio of the Emissions (1000 metric ton of CO2 equivalent) in 2000 in Cambodia to that in Cameroon?
Provide a short and direct response. 0.35. What is the ratio of the Emissions (1000 metric ton of CO2 equivalent) in 2005 in Cambodia to that in Cameroon?
Make the answer very short. 0.55. What is the ratio of the Emissions (1000 metric ton of CO2 equivalent) in 2008 in Cambodia to that in Cameroon?
Ensure brevity in your answer.  0.66. What is the ratio of the Emissions (1000 metric ton of CO2 equivalent) of 1990 in Cambodia to that in Canada?
Your answer should be very brief. 0.19. What is the ratio of the Emissions (1000 metric ton of CO2 equivalent) in 2000 in Cambodia to that in Canada?
Your answer should be compact. 0.12. What is the ratio of the Emissions (1000 metric ton of CO2 equivalent) in 2005 in Cambodia to that in Canada?
Keep it short and to the point. 0.16. What is the ratio of the Emissions (1000 metric ton of CO2 equivalent) in 2008 in Cambodia to that in Canada?
Offer a terse response. 0.34. What is the ratio of the Emissions (1000 metric ton of CO2 equivalent) in 1990 in Cambodia to that in Chile?
Make the answer very short. 0.81. What is the ratio of the Emissions (1000 metric ton of CO2 equivalent) of 2000 in Cambodia to that in Chile?
Provide a succinct answer. 0.5. What is the ratio of the Emissions (1000 metric ton of CO2 equivalent) of 2005 in Cambodia to that in Chile?
Make the answer very short. 0.63. What is the ratio of the Emissions (1000 metric ton of CO2 equivalent) of 2008 in Cambodia to that in Chile?
Your answer should be compact. 1.25. What is the ratio of the Emissions (1000 metric ton of CO2 equivalent) in 1990 in Cambodia to that in China?
Offer a terse response. 0.01. What is the ratio of the Emissions (1000 metric ton of CO2 equivalent) in 2000 in Cambodia to that in China?
Ensure brevity in your answer.  0.01. What is the ratio of the Emissions (1000 metric ton of CO2 equivalent) of 2005 in Cambodia to that in China?
Give a very brief answer. 0.01. What is the ratio of the Emissions (1000 metric ton of CO2 equivalent) of 2008 in Cambodia to that in China?
Provide a succinct answer. 0.02. What is the ratio of the Emissions (1000 metric ton of CO2 equivalent) in 1990 in Cambodia to that in Colombia?
Keep it short and to the point. 0.2. What is the ratio of the Emissions (1000 metric ton of CO2 equivalent) in 2000 in Cambodia to that in Colombia?
Your answer should be compact. 0.15. What is the ratio of the Emissions (1000 metric ton of CO2 equivalent) in 2005 in Cambodia to that in Colombia?
Offer a very short reply. 0.21. What is the ratio of the Emissions (1000 metric ton of CO2 equivalent) of 2008 in Cambodia to that in Colombia?
Provide a succinct answer. 0.39. What is the ratio of the Emissions (1000 metric ton of CO2 equivalent) in 1990 in Cameroon to that in Canada?
Provide a short and direct response. 0.41. What is the ratio of the Emissions (1000 metric ton of CO2 equivalent) in 2000 in Cameroon to that in Canada?
Keep it short and to the point. 0.33. What is the ratio of the Emissions (1000 metric ton of CO2 equivalent) in 2005 in Cameroon to that in Canada?
Provide a succinct answer. 0.29. What is the ratio of the Emissions (1000 metric ton of CO2 equivalent) in 2008 in Cameroon to that in Canada?
Give a very brief answer. 0.51. What is the ratio of the Emissions (1000 metric ton of CO2 equivalent) of 1990 in Cameroon to that in Chile?
Offer a terse response. 1.7. What is the ratio of the Emissions (1000 metric ton of CO2 equivalent) of 2000 in Cameroon to that in Chile?
Keep it short and to the point. 1.41. What is the ratio of the Emissions (1000 metric ton of CO2 equivalent) in 2005 in Cameroon to that in Chile?
Offer a very short reply. 1.14. What is the ratio of the Emissions (1000 metric ton of CO2 equivalent) in 2008 in Cameroon to that in Chile?
Your answer should be compact. 1.91. What is the ratio of the Emissions (1000 metric ton of CO2 equivalent) in 1990 in Cameroon to that in China?
Provide a short and direct response. 0.03. What is the ratio of the Emissions (1000 metric ton of CO2 equivalent) in 2000 in Cameroon to that in China?
Keep it short and to the point. 0.02. What is the ratio of the Emissions (1000 metric ton of CO2 equivalent) in 2005 in Cameroon to that in China?
Offer a terse response. 0.02. What is the ratio of the Emissions (1000 metric ton of CO2 equivalent) of 2008 in Cameroon to that in China?
Offer a terse response. 0.03. What is the ratio of the Emissions (1000 metric ton of CO2 equivalent) in 1990 in Cameroon to that in Colombia?
Ensure brevity in your answer.  0.43. What is the ratio of the Emissions (1000 metric ton of CO2 equivalent) in 2000 in Cameroon to that in Colombia?
Your response must be concise. 0.44. What is the ratio of the Emissions (1000 metric ton of CO2 equivalent) in 2005 in Cameroon to that in Colombia?
Offer a terse response. 0.37. What is the ratio of the Emissions (1000 metric ton of CO2 equivalent) of 2008 in Cameroon to that in Colombia?
Make the answer very short. 0.59. What is the ratio of the Emissions (1000 metric ton of CO2 equivalent) of 1990 in Canada to that in Chile?
Give a very brief answer. 4.15. What is the ratio of the Emissions (1000 metric ton of CO2 equivalent) of 2000 in Canada to that in Chile?
Provide a short and direct response. 4.24. What is the ratio of the Emissions (1000 metric ton of CO2 equivalent) of 2005 in Canada to that in Chile?
Your answer should be very brief. 3.96. What is the ratio of the Emissions (1000 metric ton of CO2 equivalent) in 2008 in Canada to that in Chile?
Make the answer very short. 3.71. What is the ratio of the Emissions (1000 metric ton of CO2 equivalent) in 1990 in Canada to that in China?
Your answer should be very brief. 0.07. What is the ratio of the Emissions (1000 metric ton of CO2 equivalent) of 2000 in Canada to that in China?
Offer a terse response. 0.07. What is the ratio of the Emissions (1000 metric ton of CO2 equivalent) in 2005 in Canada to that in China?
Your answer should be compact. 0.07. What is the ratio of the Emissions (1000 metric ton of CO2 equivalent) of 2008 in Canada to that in China?
Your answer should be very brief. 0.06. What is the ratio of the Emissions (1000 metric ton of CO2 equivalent) of 1990 in Canada to that in Colombia?
Your answer should be very brief. 1.05. What is the ratio of the Emissions (1000 metric ton of CO2 equivalent) in 2000 in Canada to that in Colombia?
Provide a succinct answer. 1.31. What is the ratio of the Emissions (1000 metric ton of CO2 equivalent) in 2005 in Canada to that in Colombia?
Offer a terse response. 1.29. What is the ratio of the Emissions (1000 metric ton of CO2 equivalent) of 2008 in Canada to that in Colombia?
Give a very brief answer. 1.15. What is the ratio of the Emissions (1000 metric ton of CO2 equivalent) of 1990 in Chile to that in China?
Offer a very short reply. 0.02. What is the ratio of the Emissions (1000 metric ton of CO2 equivalent) in 2000 in Chile to that in China?
Ensure brevity in your answer.  0.02. What is the ratio of the Emissions (1000 metric ton of CO2 equivalent) in 2005 in Chile to that in China?
Ensure brevity in your answer.  0.02. What is the ratio of the Emissions (1000 metric ton of CO2 equivalent) in 2008 in Chile to that in China?
Provide a short and direct response. 0.02. What is the ratio of the Emissions (1000 metric ton of CO2 equivalent) of 1990 in Chile to that in Colombia?
Your answer should be very brief. 0.25. What is the ratio of the Emissions (1000 metric ton of CO2 equivalent) in 2000 in Chile to that in Colombia?
Offer a very short reply. 0.31. What is the ratio of the Emissions (1000 metric ton of CO2 equivalent) in 2005 in Chile to that in Colombia?
Offer a very short reply. 0.33. What is the ratio of the Emissions (1000 metric ton of CO2 equivalent) in 2008 in Chile to that in Colombia?
Offer a very short reply. 0.31. What is the ratio of the Emissions (1000 metric ton of CO2 equivalent) of 1990 in China to that in Colombia?
Offer a very short reply. 15.58. What is the ratio of the Emissions (1000 metric ton of CO2 equivalent) of 2000 in China to that in Colombia?
Provide a succinct answer. 17.72. What is the ratio of the Emissions (1000 metric ton of CO2 equivalent) in 2005 in China to that in Colombia?
Your response must be concise. 18.96. What is the ratio of the Emissions (1000 metric ton of CO2 equivalent) in 2008 in China to that in Colombia?
Keep it short and to the point. 18.46. What is the difference between the highest and the second highest Emissions (1000 metric ton of CO2 equivalent) of 1990?
Your answer should be very brief. 2.36e+05. What is the difference between the highest and the second highest Emissions (1000 metric ton of CO2 equivalent) of 2000?
Your answer should be very brief. 2.81e+05. What is the difference between the highest and the second highest Emissions (1000 metric ton of CO2 equivalent) in 2005?
Make the answer very short. 3.23e+05. What is the difference between the highest and the second highest Emissions (1000 metric ton of CO2 equivalent) of 2008?
Provide a short and direct response. 3.52e+05. What is the difference between the highest and the lowest Emissions (1000 metric ton of CO2 equivalent) of 1990?
Provide a short and direct response. 2.50e+05. What is the difference between the highest and the lowest Emissions (1000 metric ton of CO2 equivalent) in 2000?
Provide a short and direct response. 3.01e+05. What is the difference between the highest and the lowest Emissions (1000 metric ton of CO2 equivalent) of 2005?
Offer a very short reply. 3.43e+05. What is the difference between the highest and the lowest Emissions (1000 metric ton of CO2 equivalent) of 2008?
Make the answer very short. 3.69e+05. 